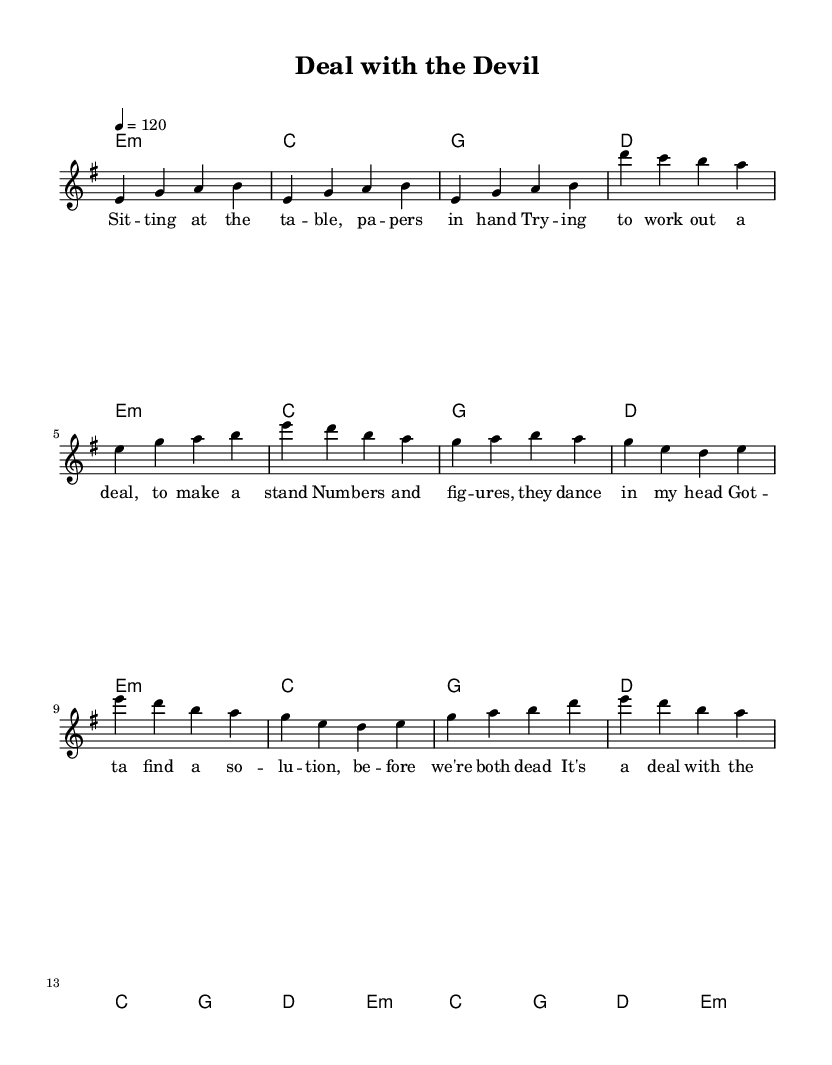What is the key signature of this music? The key signature is E minor, which has one sharp (F#).
Answer: E minor What is the time signature of this music? The time signature is 4/4, indicating four beats per measure.
Answer: 4/4 What is the tempo marking of this music? The tempo marking is 120 beats per minute, specified at the beginning of the piece.
Answer: 120 What chords are used in the chorus? The chords in the chorus are C, G, D, and E minor. These can be found in the harmony section directly under the melody.
Answer: C, G, D, E minor How many measures are in the verse section? The verse section consists of eight measures, which can be counted directly from the melody line.
Answer: Eight How does the melody in the chorus compare to the verse? The melody in the chorus is higher in pitch and features a more repetitive structure compared to the verse, enhancing its memorable quality.
Answer: Higher and repetitive What is the primary theme of the lyrics in this song? The primary theme is negotiation and compromise, clearly reflected in the lyrics about working out a deal.
Answer: Negotiation and compromise 